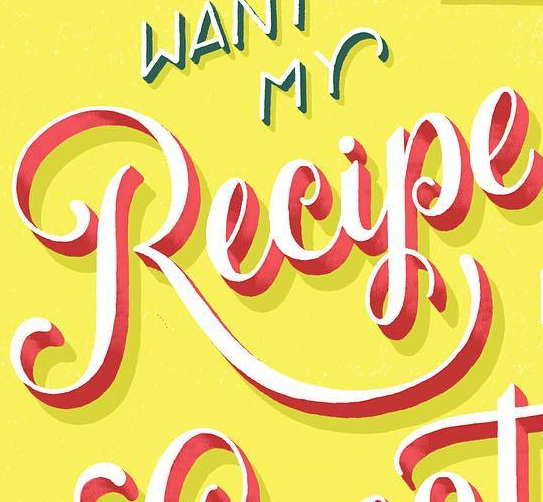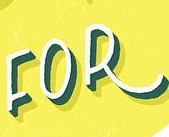Read the text from these images in sequence, separated by a semicolon. Recipe; FOR 